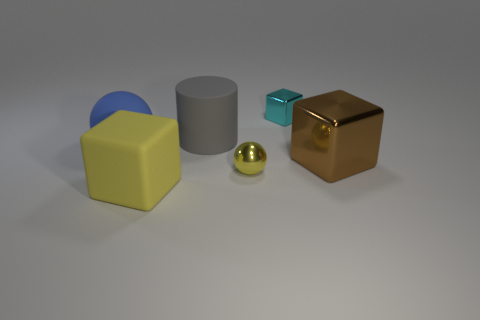Subtract all large brown cubes. How many cubes are left? 2 Subtract 1 cubes. How many cubes are left? 2 Subtract all gray cubes. Subtract all brown cylinders. How many cubes are left? 3 Add 3 tiny yellow shiny cylinders. How many objects exist? 9 Subtract all balls. How many objects are left? 4 Add 1 big brown things. How many big brown things exist? 2 Subtract 0 gray blocks. How many objects are left? 6 Subtract all brown metallic blocks. Subtract all rubber cubes. How many objects are left? 4 Add 1 large matte spheres. How many large matte spheres are left? 2 